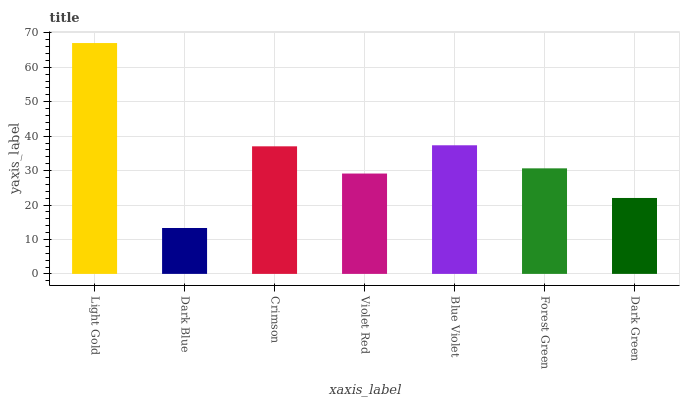Is Dark Blue the minimum?
Answer yes or no. Yes. Is Light Gold the maximum?
Answer yes or no. Yes. Is Crimson the minimum?
Answer yes or no. No. Is Crimson the maximum?
Answer yes or no. No. Is Crimson greater than Dark Blue?
Answer yes or no. Yes. Is Dark Blue less than Crimson?
Answer yes or no. Yes. Is Dark Blue greater than Crimson?
Answer yes or no. No. Is Crimson less than Dark Blue?
Answer yes or no. No. Is Forest Green the high median?
Answer yes or no. Yes. Is Forest Green the low median?
Answer yes or no. Yes. Is Dark Green the high median?
Answer yes or no. No. Is Blue Violet the low median?
Answer yes or no. No. 